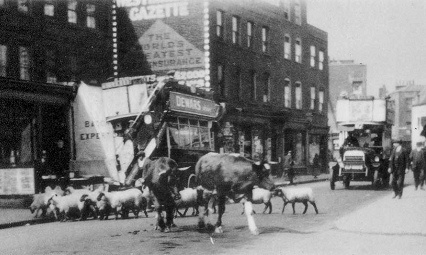Describe the objects in this image and their specific colors. I can see truck in darkgray, black, gray, and lightgray tones, cow in darkgray, black, gray, and lightgray tones, cow in darkgray, black, gray, and lightgray tones, people in darkgray, black, gray, and lightgray tones, and sheep in darkgray, lightgray, black, and gray tones in this image. 